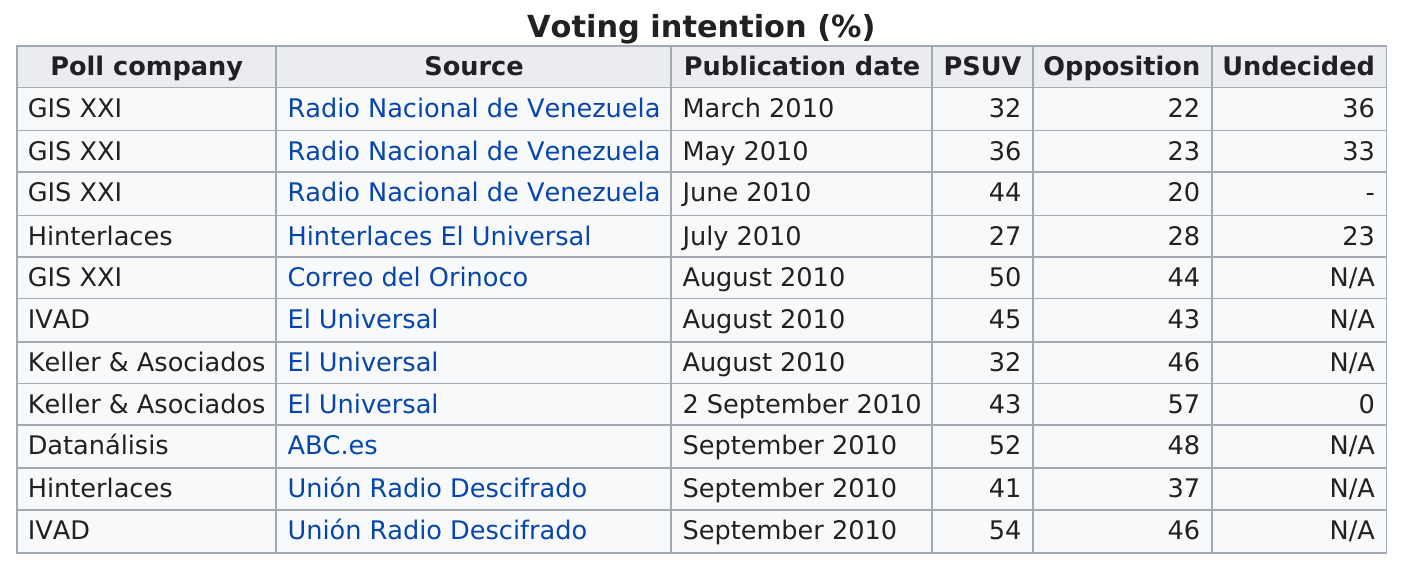Outline some significant characteristics in this image. The poll company is listed for 3 consecutive times in GIS XXI. As of the company GIS XXI's latest data, there have been a total of 4 polls published. The poll company with the highest number of undecided votes was GIS XXI. There are 5 different poll companies listed. On May 2010, there were 23 people who were in opposition. 